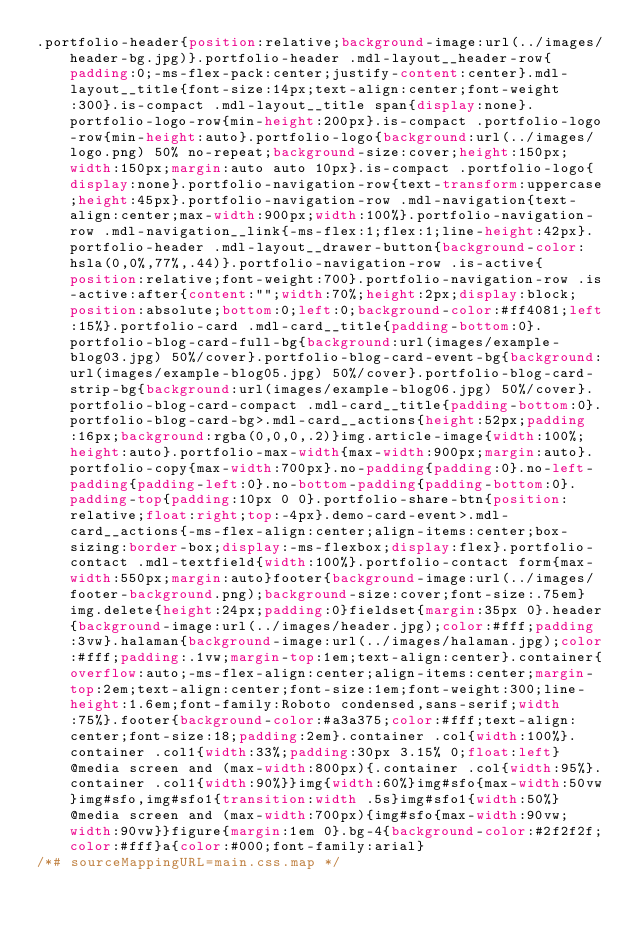Convert code to text. <code><loc_0><loc_0><loc_500><loc_500><_CSS_>.portfolio-header{position:relative;background-image:url(../images/header-bg.jpg)}.portfolio-header .mdl-layout__header-row{padding:0;-ms-flex-pack:center;justify-content:center}.mdl-layout__title{font-size:14px;text-align:center;font-weight:300}.is-compact .mdl-layout__title span{display:none}.portfolio-logo-row{min-height:200px}.is-compact .portfolio-logo-row{min-height:auto}.portfolio-logo{background:url(../images/logo.png) 50% no-repeat;background-size:cover;height:150px;width:150px;margin:auto auto 10px}.is-compact .portfolio-logo{display:none}.portfolio-navigation-row{text-transform:uppercase;height:45px}.portfolio-navigation-row .mdl-navigation{text-align:center;max-width:900px;width:100%}.portfolio-navigation-row .mdl-navigation__link{-ms-flex:1;flex:1;line-height:42px}.portfolio-header .mdl-layout__drawer-button{background-color:hsla(0,0%,77%,.44)}.portfolio-navigation-row .is-active{position:relative;font-weight:700}.portfolio-navigation-row .is-active:after{content:"";width:70%;height:2px;display:block;position:absolute;bottom:0;left:0;background-color:#ff4081;left:15%}.portfolio-card .mdl-card__title{padding-bottom:0}.portfolio-blog-card-full-bg{background:url(images/example-blog03.jpg) 50%/cover}.portfolio-blog-card-event-bg{background:url(images/example-blog05.jpg) 50%/cover}.portfolio-blog-card-strip-bg{background:url(images/example-blog06.jpg) 50%/cover}.portfolio-blog-card-compact .mdl-card__title{padding-bottom:0}.portfolio-blog-card-bg>.mdl-card__actions{height:52px;padding:16px;background:rgba(0,0,0,.2)}img.article-image{width:100%;height:auto}.portfolio-max-width{max-width:900px;margin:auto}.portfolio-copy{max-width:700px}.no-padding{padding:0}.no-left-padding{padding-left:0}.no-bottom-padding{padding-bottom:0}.padding-top{padding:10px 0 0}.portfolio-share-btn{position:relative;float:right;top:-4px}.demo-card-event>.mdl-card__actions{-ms-flex-align:center;align-items:center;box-sizing:border-box;display:-ms-flexbox;display:flex}.portfolio-contact .mdl-textfield{width:100%}.portfolio-contact form{max-width:550px;margin:auto}footer{background-image:url(../images/footer-background.png);background-size:cover;font-size:.75em}img.delete{height:24px;padding:0}fieldset{margin:35px 0}.header{background-image:url(../images/header.jpg);color:#fff;padding:3vw}.halaman{background-image:url(../images/halaman.jpg);color:#fff;padding:.1vw;margin-top:1em;text-align:center}.container{overflow:auto;-ms-flex-align:center;align-items:center;margin-top:2em;text-align:center;font-size:1em;font-weight:300;line-height:1.6em;font-family:Roboto condensed,sans-serif;width:75%}.footer{background-color:#a3a375;color:#fff;text-align:center;font-size:18;padding:2em}.container .col{width:100%}.container .col1{width:33%;padding:30px 3.15% 0;float:left}@media screen and (max-width:800px){.container .col{width:95%}.container .col1{width:90%}}img{width:60%}img#sfo{max-width:50vw}img#sfo,img#sfo1{transition:width .5s}img#sfo1{width:50%}@media screen and (max-width:700px){img#sfo{max-width:90vw;width:90vw}}figure{margin:1em 0}.bg-4{background-color:#2f2f2f;color:#fff}a{color:#000;font-family:arial}
/*# sourceMappingURL=main.css.map */
</code> 